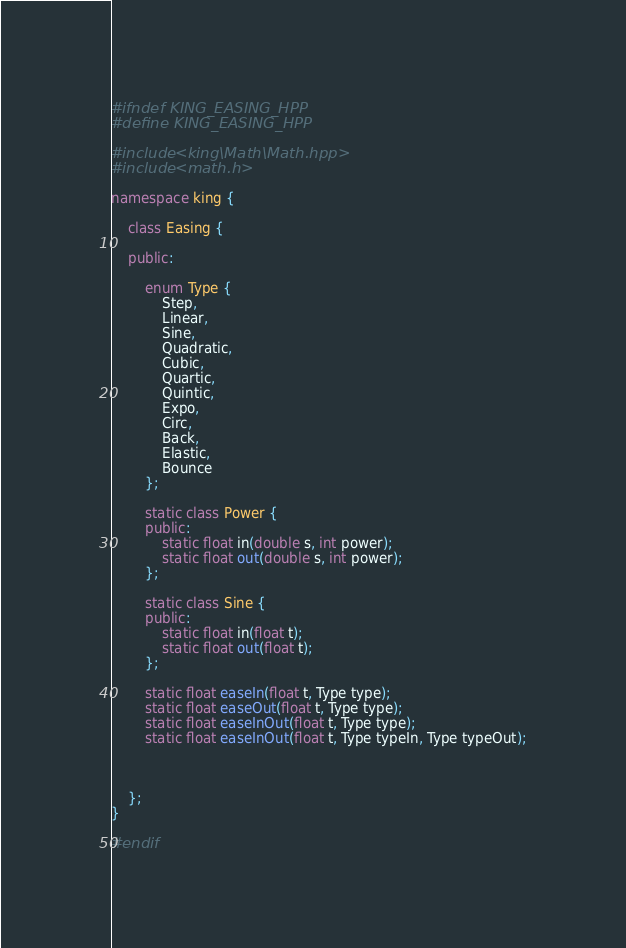Convert code to text. <code><loc_0><loc_0><loc_500><loc_500><_C++_>


#ifndef KING_EASING_HPP
#define KING_EASING_HPP

#include <king\Math\Math.hpp>
#include <math.h>

namespace king {

	class Easing {

	public:

		enum Type {
			Step,
			Linear,
			Sine,
			Quadratic,
			Cubic,
			Quartic,
			Quintic,
			Expo,
			Circ,
			Back,
			Elastic,
			Bounce
		};

		static class Power {
		public:
			static float in(double s, int power);
			static float out(double s, int power);
		};

		static class Sine {
		public:
			static float in(float t);
			static float out(float t);
		};

		static float easeIn(float t, Type type);
		static float easeOut(float t, Type type);
		static float easeInOut(float t, Type type);
		static float easeInOut(float t, Type typeIn, Type typeOut);

		
	
	};
}

#endif</code> 